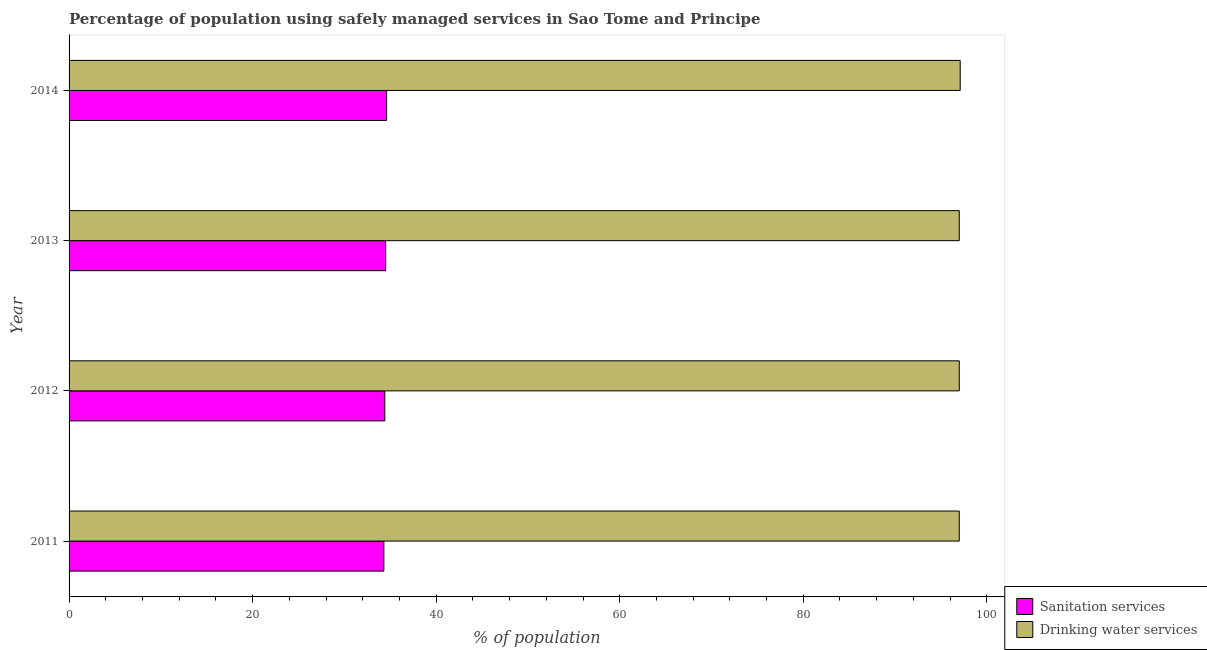How many different coloured bars are there?
Offer a very short reply. 2. Are the number of bars per tick equal to the number of legend labels?
Your answer should be very brief. Yes. How many bars are there on the 1st tick from the bottom?
Offer a very short reply. 2. What is the percentage of population who used drinking water services in 2014?
Offer a very short reply. 97.1. Across all years, what is the maximum percentage of population who used drinking water services?
Offer a terse response. 97.1. Across all years, what is the minimum percentage of population who used sanitation services?
Keep it short and to the point. 34.3. What is the total percentage of population who used drinking water services in the graph?
Ensure brevity in your answer.  388.1. What is the difference between the percentage of population who used drinking water services in 2011 and that in 2012?
Your answer should be compact. 0. What is the difference between the percentage of population who used sanitation services in 2011 and the percentage of population who used drinking water services in 2014?
Provide a short and direct response. -62.8. What is the average percentage of population who used drinking water services per year?
Your answer should be very brief. 97.03. In the year 2012, what is the difference between the percentage of population who used sanitation services and percentage of population who used drinking water services?
Provide a short and direct response. -62.6. In how many years, is the percentage of population who used sanitation services greater than 48 %?
Your answer should be compact. 0. What is the difference between the highest and the lowest percentage of population who used sanitation services?
Your answer should be very brief. 0.3. Is the sum of the percentage of population who used drinking water services in 2011 and 2014 greater than the maximum percentage of population who used sanitation services across all years?
Provide a short and direct response. Yes. What does the 2nd bar from the top in 2011 represents?
Offer a terse response. Sanitation services. What does the 1st bar from the bottom in 2013 represents?
Offer a very short reply. Sanitation services. How many bars are there?
Provide a succinct answer. 8. How many years are there in the graph?
Your response must be concise. 4. Are the values on the major ticks of X-axis written in scientific E-notation?
Your answer should be compact. No. Where does the legend appear in the graph?
Ensure brevity in your answer.  Bottom right. What is the title of the graph?
Your response must be concise. Percentage of population using safely managed services in Sao Tome and Principe. What is the label or title of the X-axis?
Keep it short and to the point. % of population. What is the % of population in Sanitation services in 2011?
Make the answer very short. 34.3. What is the % of population in Drinking water services in 2011?
Your response must be concise. 97. What is the % of population in Sanitation services in 2012?
Provide a succinct answer. 34.4. What is the % of population of Drinking water services in 2012?
Ensure brevity in your answer.  97. What is the % of population of Sanitation services in 2013?
Your response must be concise. 34.5. What is the % of population of Drinking water services in 2013?
Provide a succinct answer. 97. What is the % of population in Sanitation services in 2014?
Provide a succinct answer. 34.6. What is the % of population in Drinking water services in 2014?
Provide a succinct answer. 97.1. Across all years, what is the maximum % of population of Sanitation services?
Your response must be concise. 34.6. Across all years, what is the maximum % of population of Drinking water services?
Your answer should be very brief. 97.1. Across all years, what is the minimum % of population in Sanitation services?
Provide a succinct answer. 34.3. Across all years, what is the minimum % of population of Drinking water services?
Provide a succinct answer. 97. What is the total % of population in Sanitation services in the graph?
Offer a very short reply. 137.8. What is the total % of population of Drinking water services in the graph?
Offer a terse response. 388.1. What is the difference between the % of population of Drinking water services in 2011 and that in 2012?
Your answer should be very brief. 0. What is the difference between the % of population in Sanitation services in 2011 and that in 2013?
Provide a succinct answer. -0.2. What is the difference between the % of population in Drinking water services in 2011 and that in 2014?
Your answer should be compact. -0.1. What is the difference between the % of population in Drinking water services in 2012 and that in 2013?
Provide a short and direct response. 0. What is the difference between the % of population of Sanitation services in 2012 and that in 2014?
Provide a short and direct response. -0.2. What is the difference between the % of population of Sanitation services in 2013 and that in 2014?
Provide a short and direct response. -0.1. What is the difference between the % of population in Sanitation services in 2011 and the % of population in Drinking water services in 2012?
Offer a terse response. -62.7. What is the difference between the % of population in Sanitation services in 2011 and the % of population in Drinking water services in 2013?
Your answer should be very brief. -62.7. What is the difference between the % of population of Sanitation services in 2011 and the % of population of Drinking water services in 2014?
Keep it short and to the point. -62.8. What is the difference between the % of population in Sanitation services in 2012 and the % of population in Drinking water services in 2013?
Your answer should be very brief. -62.6. What is the difference between the % of population in Sanitation services in 2012 and the % of population in Drinking water services in 2014?
Your response must be concise. -62.7. What is the difference between the % of population in Sanitation services in 2013 and the % of population in Drinking water services in 2014?
Keep it short and to the point. -62.6. What is the average % of population in Sanitation services per year?
Your response must be concise. 34.45. What is the average % of population in Drinking water services per year?
Give a very brief answer. 97.03. In the year 2011, what is the difference between the % of population in Sanitation services and % of population in Drinking water services?
Your response must be concise. -62.7. In the year 2012, what is the difference between the % of population in Sanitation services and % of population in Drinking water services?
Provide a short and direct response. -62.6. In the year 2013, what is the difference between the % of population of Sanitation services and % of population of Drinking water services?
Provide a succinct answer. -62.5. In the year 2014, what is the difference between the % of population in Sanitation services and % of population in Drinking water services?
Offer a terse response. -62.5. What is the ratio of the % of population of Sanitation services in 2011 to that in 2012?
Give a very brief answer. 1. What is the ratio of the % of population of Drinking water services in 2011 to that in 2012?
Make the answer very short. 1. What is the ratio of the % of population of Sanitation services in 2011 to that in 2013?
Offer a terse response. 0.99. What is the ratio of the % of population of Sanitation services in 2011 to that in 2014?
Make the answer very short. 0.99. What is the ratio of the % of population of Drinking water services in 2011 to that in 2014?
Offer a terse response. 1. What is the ratio of the % of population of Sanitation services in 2012 to that in 2013?
Provide a succinct answer. 1. What is the ratio of the % of population of Drinking water services in 2012 to that in 2013?
Your answer should be very brief. 1. What is the ratio of the % of population of Drinking water services in 2012 to that in 2014?
Offer a very short reply. 1. What is the difference between the highest and the second highest % of population in Sanitation services?
Keep it short and to the point. 0.1. What is the difference between the highest and the lowest % of population in Drinking water services?
Your answer should be very brief. 0.1. 